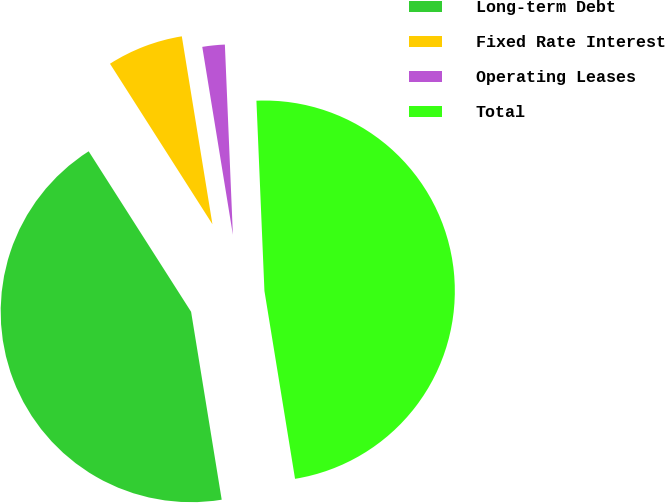Convert chart to OTSL. <chart><loc_0><loc_0><loc_500><loc_500><pie_chart><fcel>Long-term Debt<fcel>Fixed Rate Interest<fcel>Operating Leases<fcel>Total<nl><fcel>43.53%<fcel>6.47%<fcel>1.9%<fcel>48.1%<nl></chart> 